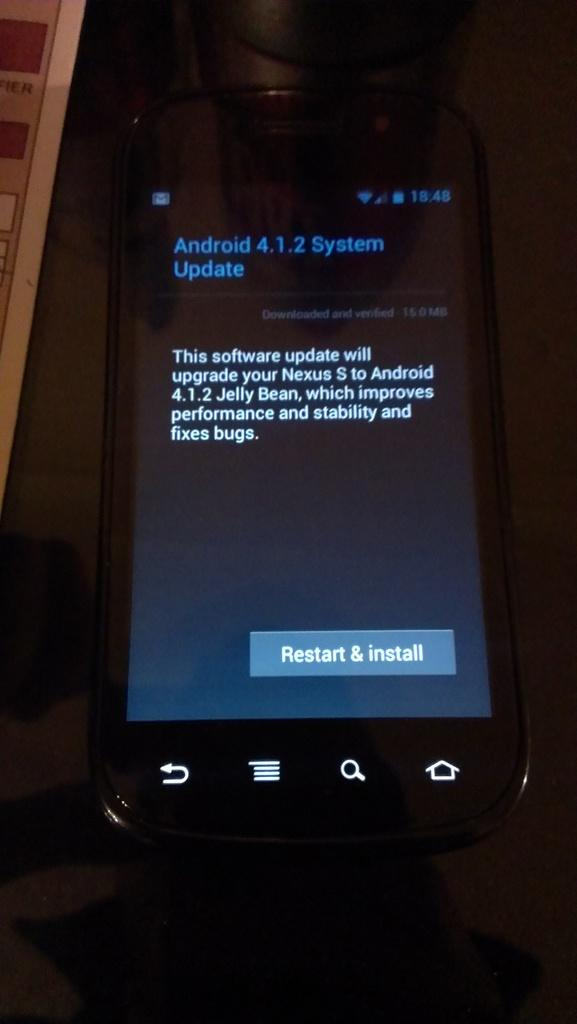What electronic device is visible in the image? There is a cellular phone in the image. What is displayed on the screen of the cellular phone? There is text displayed on the screen of the cellular phone. Can you see any seashore or soda in the image? No, there is no seashore or soda present in the image. Is there a wing visible in the image? No, there is no wing present in the image. 